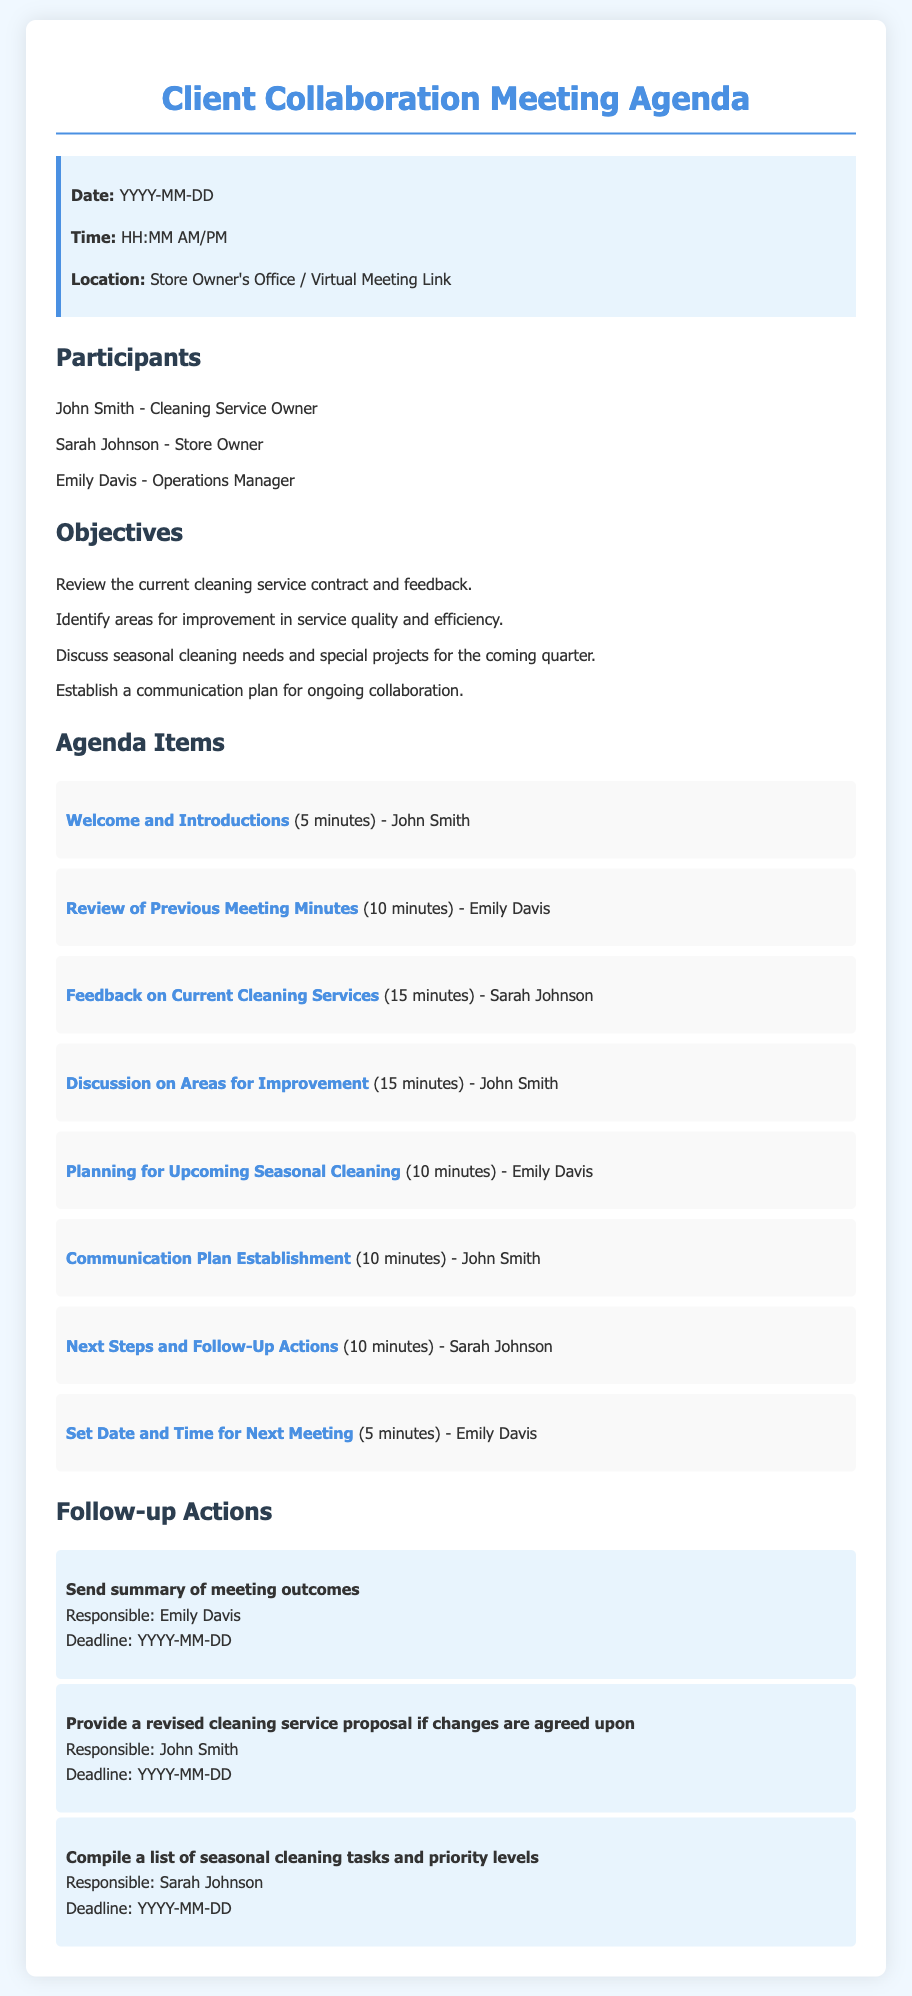what is the date of the meeting? The meeting date is specified as YYYY-MM-DD in the document.
Answer: YYYY-MM-DD who is the cleaning service owner? The document lists John Smith as the cleaning service owner.
Answer: John Smith how long is the feedback discussion scheduled? The document states that the feedback discussion is scheduled for 15 minutes.
Answer: 15 minutes who is responsible for sending the summary of meeting outcomes? The follow-up action indicates that Emily Davis is responsible for this task.
Answer: Emily Davis what is one of the objectives of the meeting? The objectives listed include reviewing the current cleaning service contract and feedback.
Answer: Review the current cleaning service contract and feedback how many participants are listed in the meeting agenda? The document lists three participants in the meeting agenda.
Answer: Three participants when is the deadline for compiling a list of seasonal cleaning tasks? The document mentions that the deadline is set for YYYY-MM-DD.
Answer: YYYY-MM-DD what is the first agenda item listed? The first agenda item is "Welcome and Introductions".
Answer: Welcome and Introductions what is the total time allocated for planning upcoming seasonal cleaning? According to the agenda, the time allocated for planning is 10 minutes.
Answer: 10 minutes 